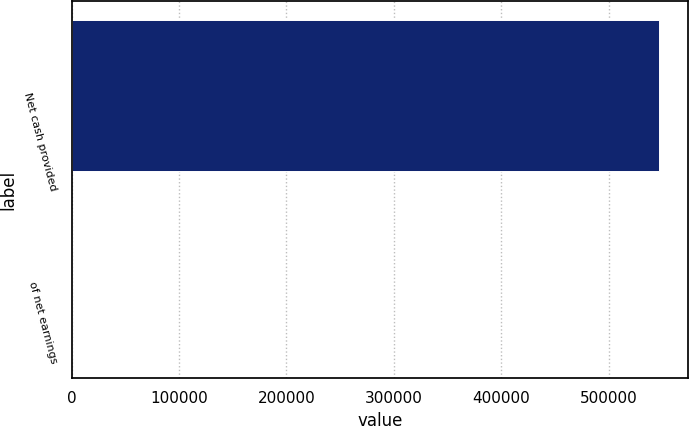Convert chart to OTSL. <chart><loc_0><loc_0><loc_500><loc_500><bar_chart><fcel>Net cash provided<fcel>of net earnings<nl><fcel>546940<fcel>105.9<nl></chart> 